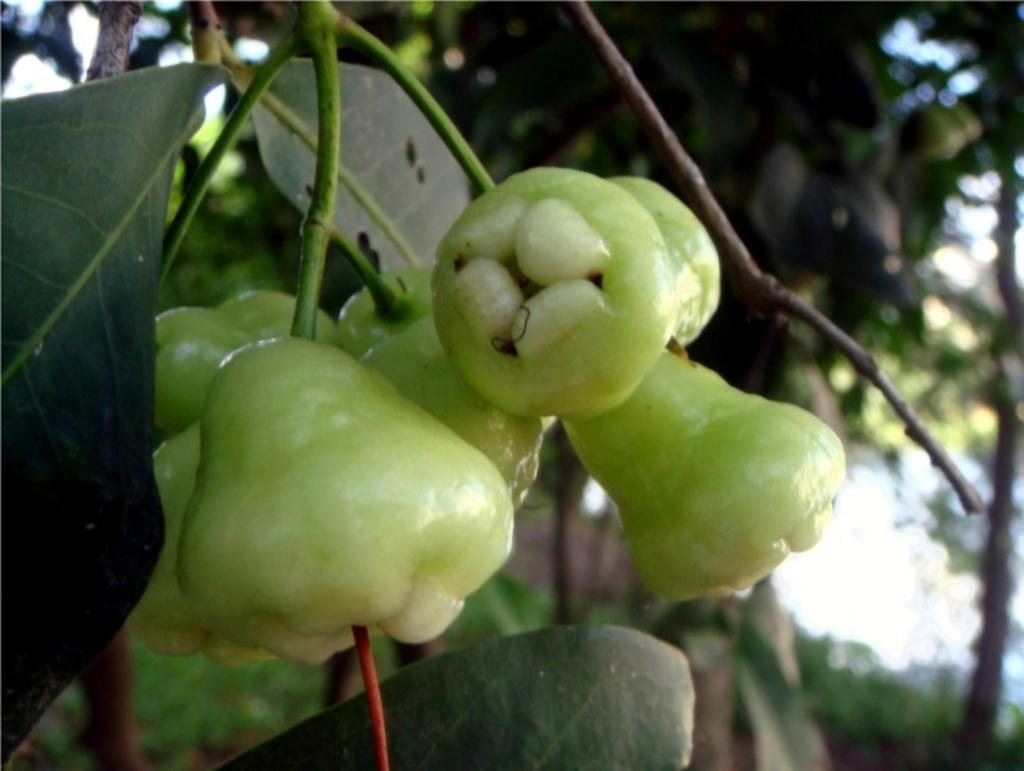Where was the image taken? The image was taken outdoors. What can be seen in the background of the image? There are trees with green leaves in the background. What is the main subject of the image? The main subject of the image is a few fruits. What is the color of the fruits? The fruits are green in color. Can you tell me how many cushions are visible in the image? There are no cushions present in the image. What type of sheet is covering the fruits in the image? There is no sheet covering the fruits in the image; they are not covered at all. 